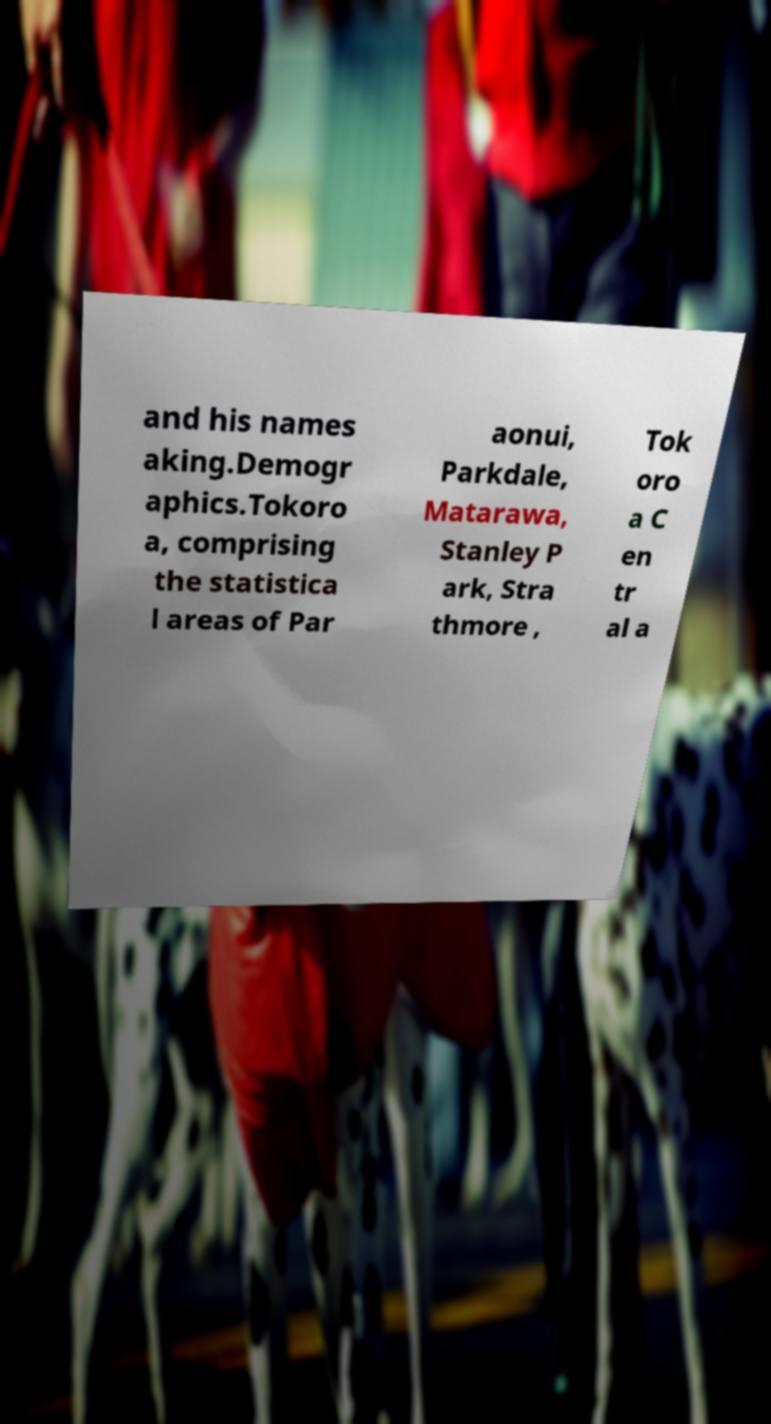Could you assist in decoding the text presented in this image and type it out clearly? and his names aking.Demogr aphics.Tokoro a, comprising the statistica l areas of Par aonui, Parkdale, Matarawa, Stanley P ark, Stra thmore , Tok oro a C en tr al a 